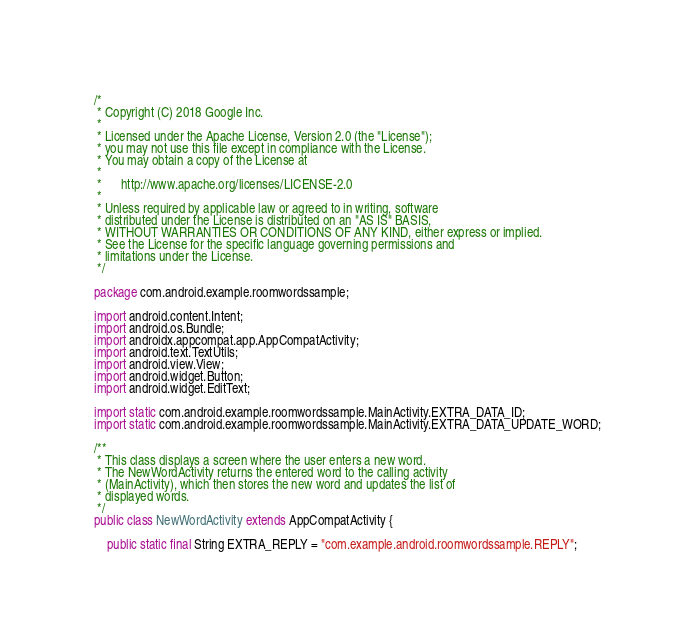Convert code to text. <code><loc_0><loc_0><loc_500><loc_500><_Java_>/*
 * Copyright (C) 2018 Google Inc.
 *
 * Licensed under the Apache License, Version 2.0 (the "License");
 * you may not use this file except in compliance with the License.
 * You may obtain a copy of the License at
 *
 *      http://www.apache.org/licenses/LICENSE-2.0
 *
 * Unless required by applicable law or agreed to in writing, software
 * distributed under the License is distributed on an "AS IS" BASIS,
 * WITHOUT WARRANTIES OR CONDITIONS OF ANY KIND, either express or implied.
 * See the License for the specific language governing permissions and
 * limitations under the License.
 */

package com.android.example.roomwordssample;

import android.content.Intent;
import android.os.Bundle;
import androidx.appcompat.app.AppCompatActivity;
import android.text.TextUtils;
import android.view.View;
import android.widget.Button;
import android.widget.EditText;

import static com.android.example.roomwordssample.MainActivity.EXTRA_DATA_ID;
import static com.android.example.roomwordssample.MainActivity.EXTRA_DATA_UPDATE_WORD;

/**
 * This class displays a screen where the user enters a new word.
 * The NewWordActivity returns the entered word to the calling activity
 * (MainActivity), which then stores the new word and updates the list of
 * displayed words.
 */
public class NewWordActivity extends AppCompatActivity {

    public static final String EXTRA_REPLY = "com.example.android.roomwordssample.REPLY";</code> 